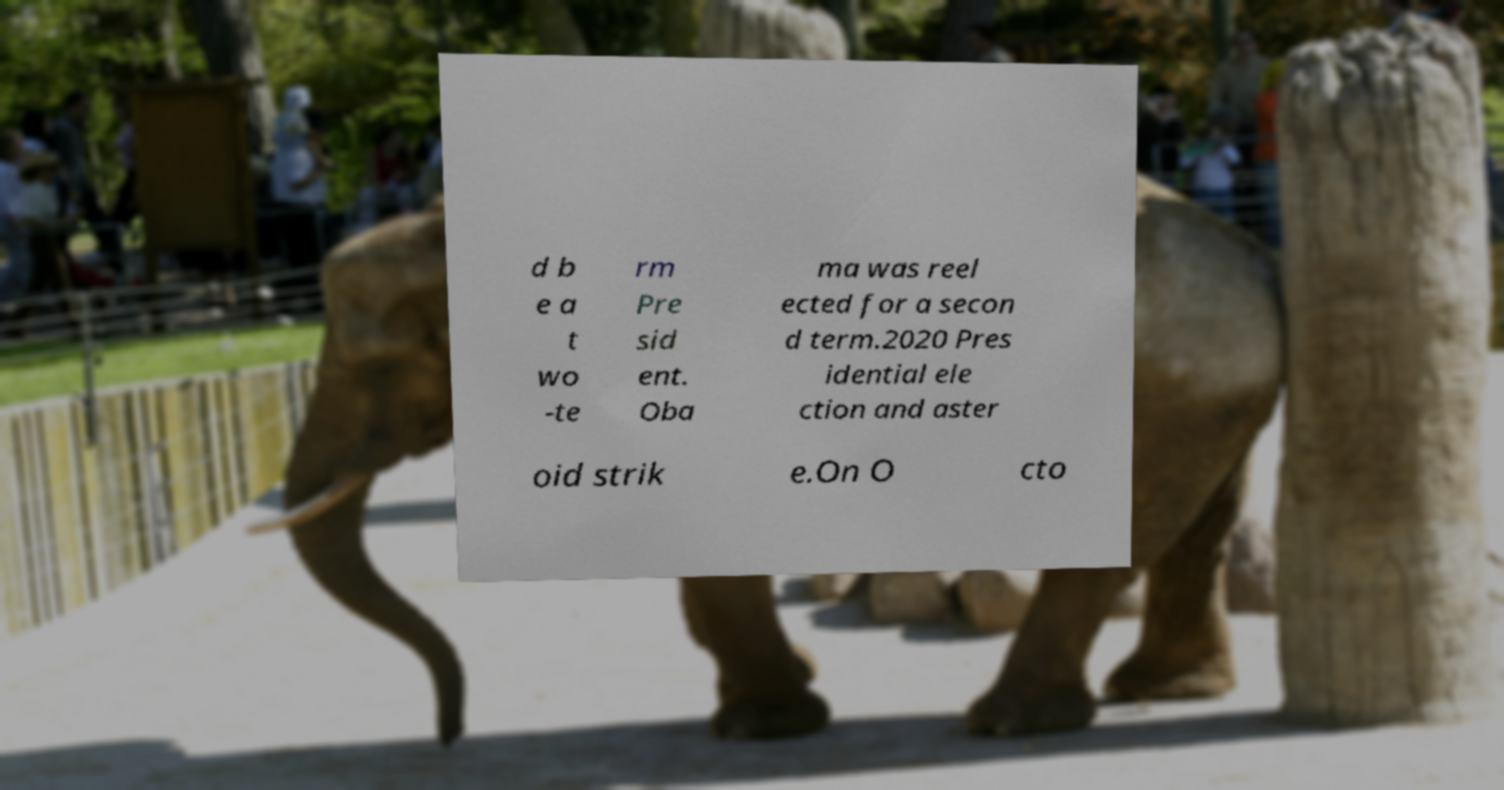Please read and relay the text visible in this image. What does it say? d b e a t wo -te rm Pre sid ent. Oba ma was reel ected for a secon d term.2020 Pres idential ele ction and aster oid strik e.On O cto 